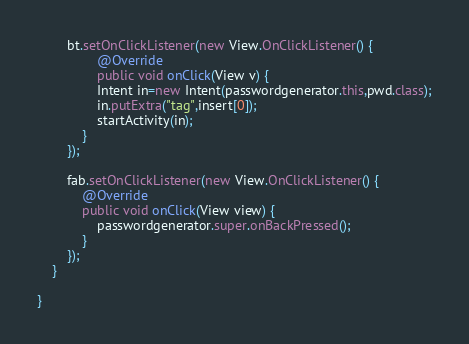<code> <loc_0><loc_0><loc_500><loc_500><_Java_>        bt.setOnClickListener(new View.OnClickListener() {
                @Override
                public void onClick(View v) {
                Intent in=new Intent(passwordgenerator.this,pwd.class);
                in.putExtra("tag",insert[0]);
                startActivity(in);
            }
        });

        fab.setOnClickListener(new View.OnClickListener() {
            @Override
            public void onClick(View view) {
                passwordgenerator.super.onBackPressed();
            }
        });
    }

}
</code> 